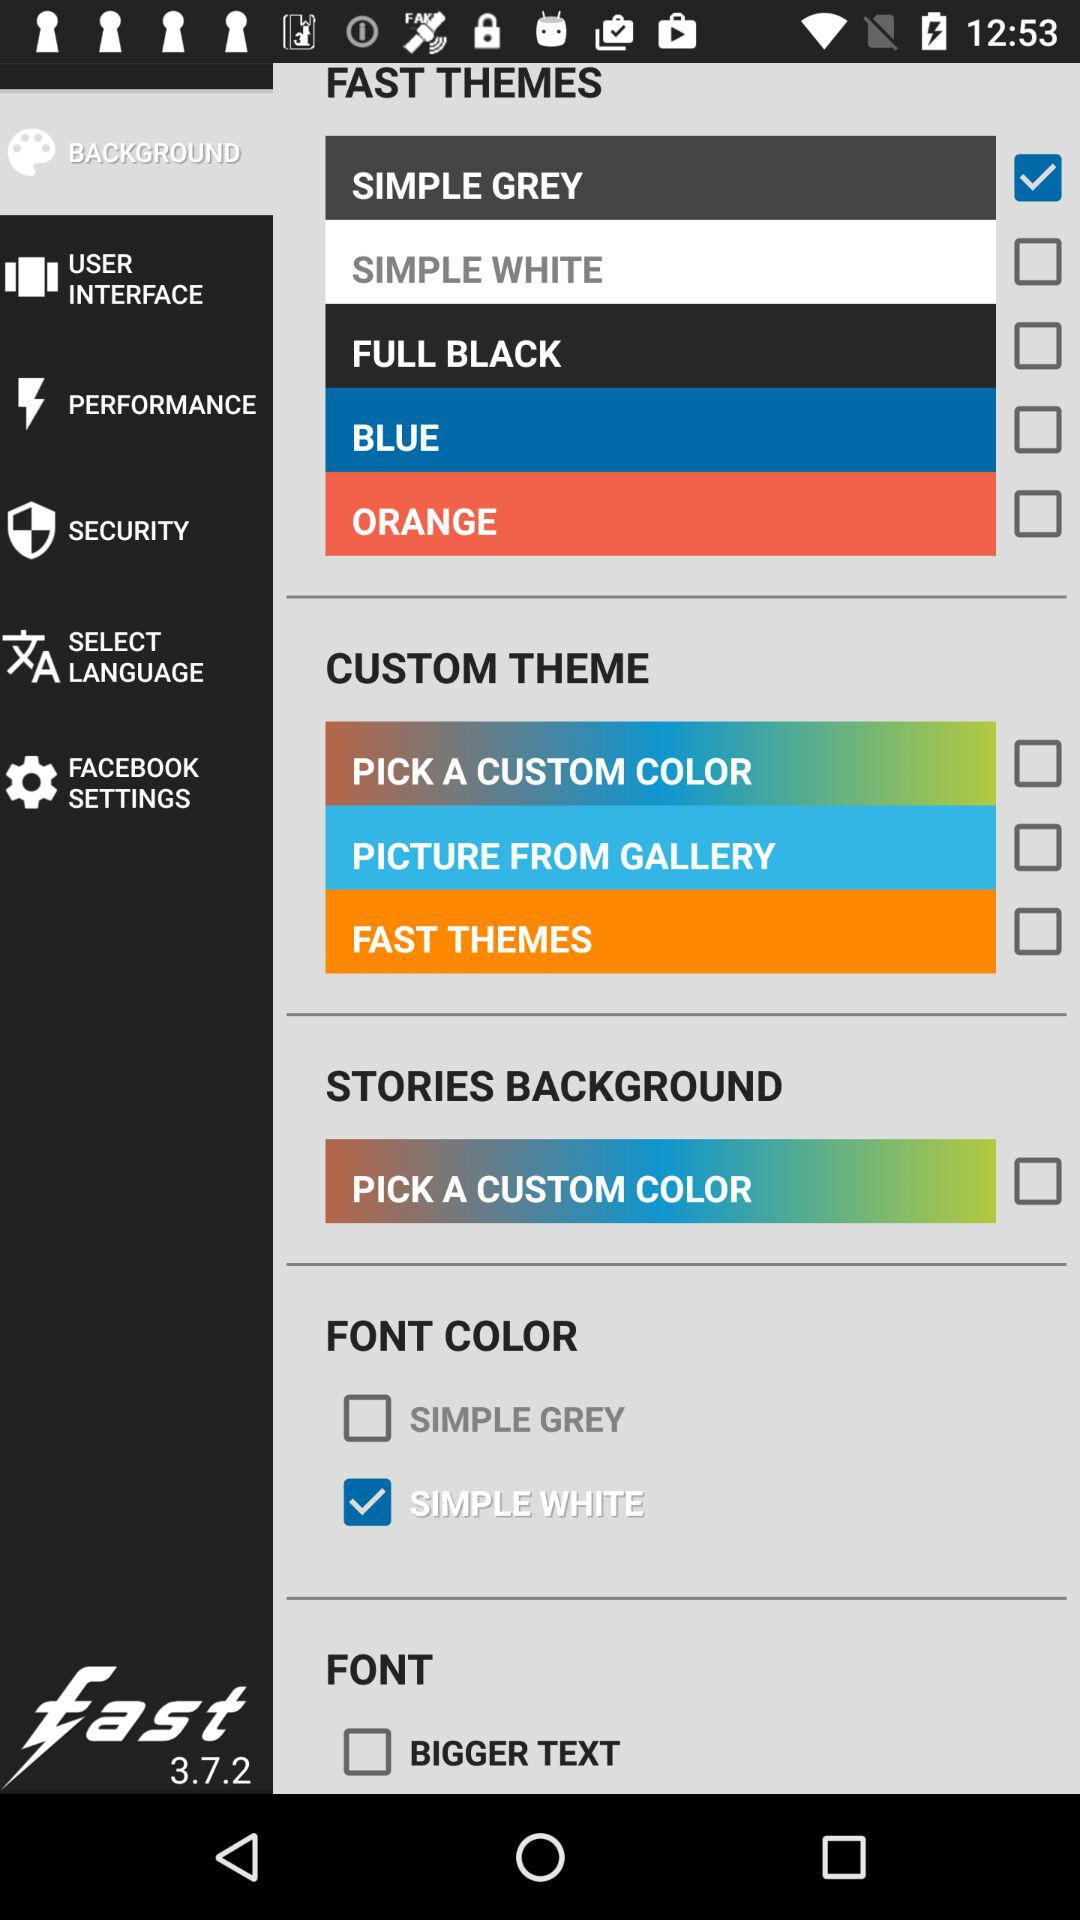What is the version of "Fast"? The version is 3.7.2. 